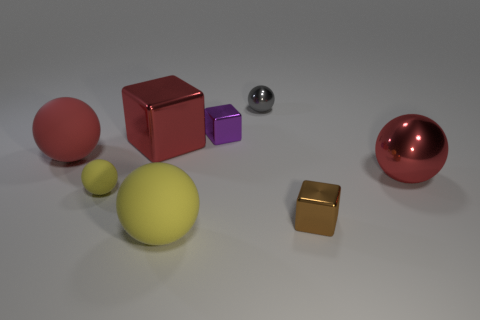Is there a brown object made of the same material as the gray thing?
Make the answer very short. Yes. Do the large red shiny thing behind the large red metal sphere and the small shiny thing that is in front of the small yellow sphere have the same shape?
Offer a very short reply. Yes. Is there a metallic block?
Provide a succinct answer. Yes. There is a metal block that is the same size as the red matte sphere; what is its color?
Offer a terse response. Red. How many gray things have the same shape as the tiny brown thing?
Provide a succinct answer. 0. Do the thing to the left of the tiny rubber sphere and the gray thing have the same material?
Keep it short and to the point. No. How many balls are tiny matte objects or small purple things?
Provide a short and direct response. 1. There is a matte object that is on the right side of the yellow matte ball behind the small metallic object right of the tiny gray ball; what shape is it?
Give a very brief answer. Sphere. What shape is the shiny object that is the same color as the big cube?
Make the answer very short. Sphere. How many gray objects have the same size as the purple thing?
Make the answer very short. 1. 